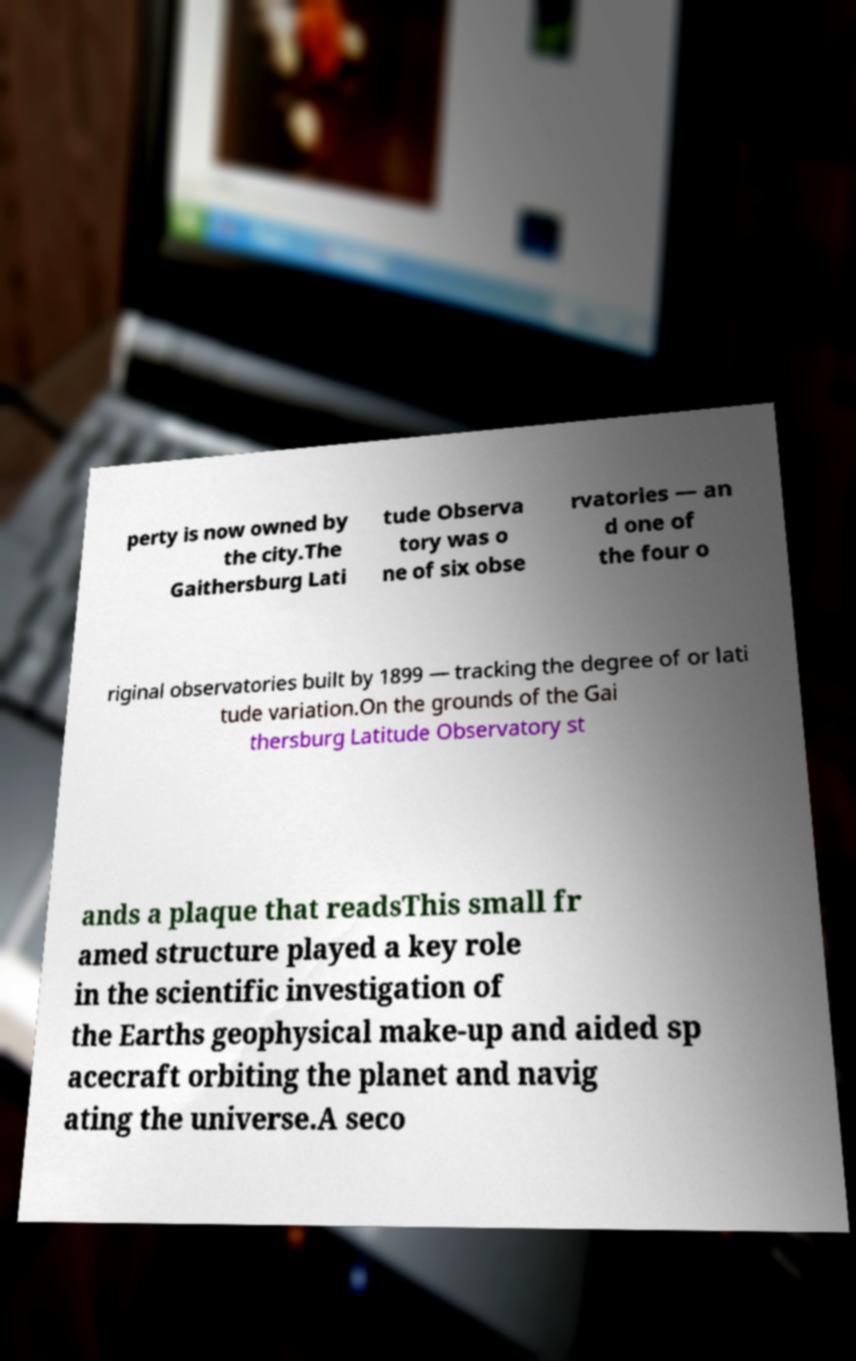Can you accurately transcribe the text from the provided image for me? perty is now owned by the city.The Gaithersburg Lati tude Observa tory was o ne of six obse rvatories — an d one of the four o riginal observatories built by 1899 — tracking the degree of or lati tude variation.On the grounds of the Gai thersburg Latitude Observatory st ands a plaque that readsThis small fr amed structure played a key role in the scientific investigation of the Earths geophysical make-up and aided sp acecraft orbiting the planet and navig ating the universe.A seco 